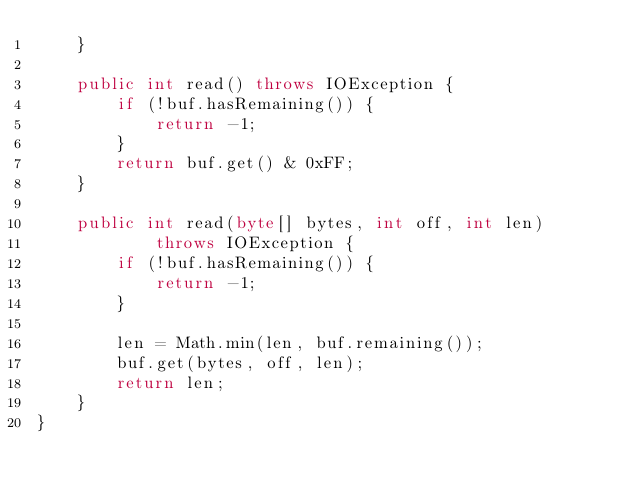Convert code to text. <code><loc_0><loc_0><loc_500><loc_500><_Java_>    }

    public int read() throws IOException {
        if (!buf.hasRemaining()) {
            return -1;
        }
        return buf.get() & 0xFF;
    }

    public int read(byte[] bytes, int off, int len)
            throws IOException {
        if (!buf.hasRemaining()) {
            return -1;
        }

        len = Math.min(len, buf.remaining());
        buf.get(bytes, off, len);
        return len;
    }
}
</code> 